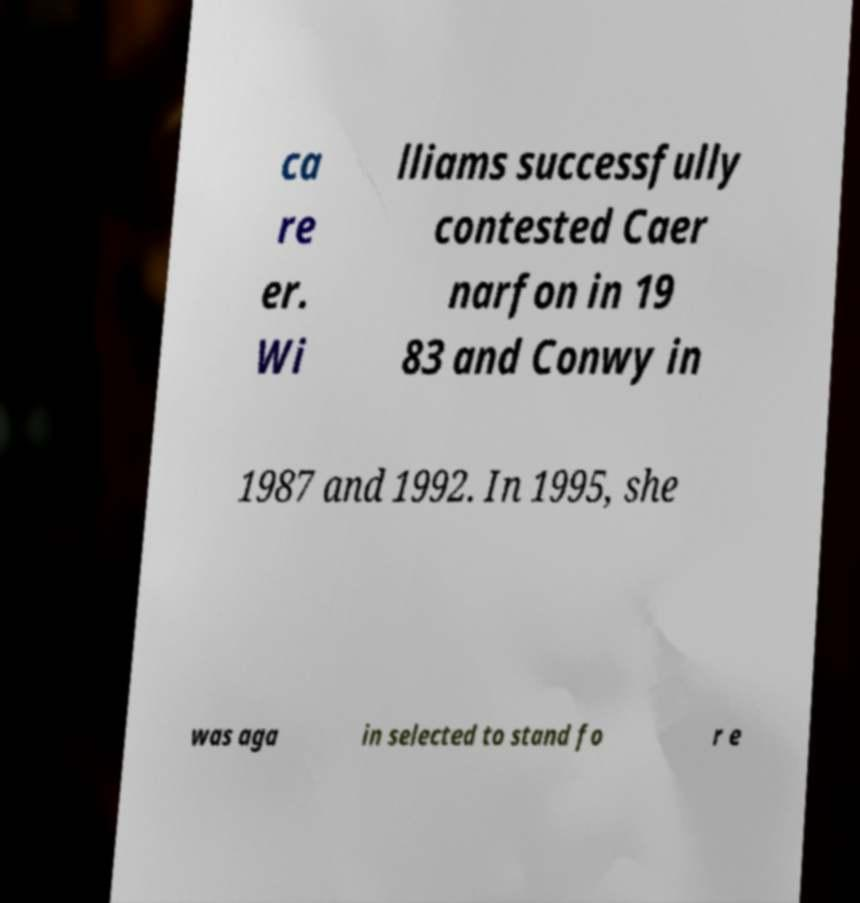Please read and relay the text visible in this image. What does it say? ca re er. Wi lliams successfully contested Caer narfon in 19 83 and Conwy in 1987 and 1992. In 1995, she was aga in selected to stand fo r e 